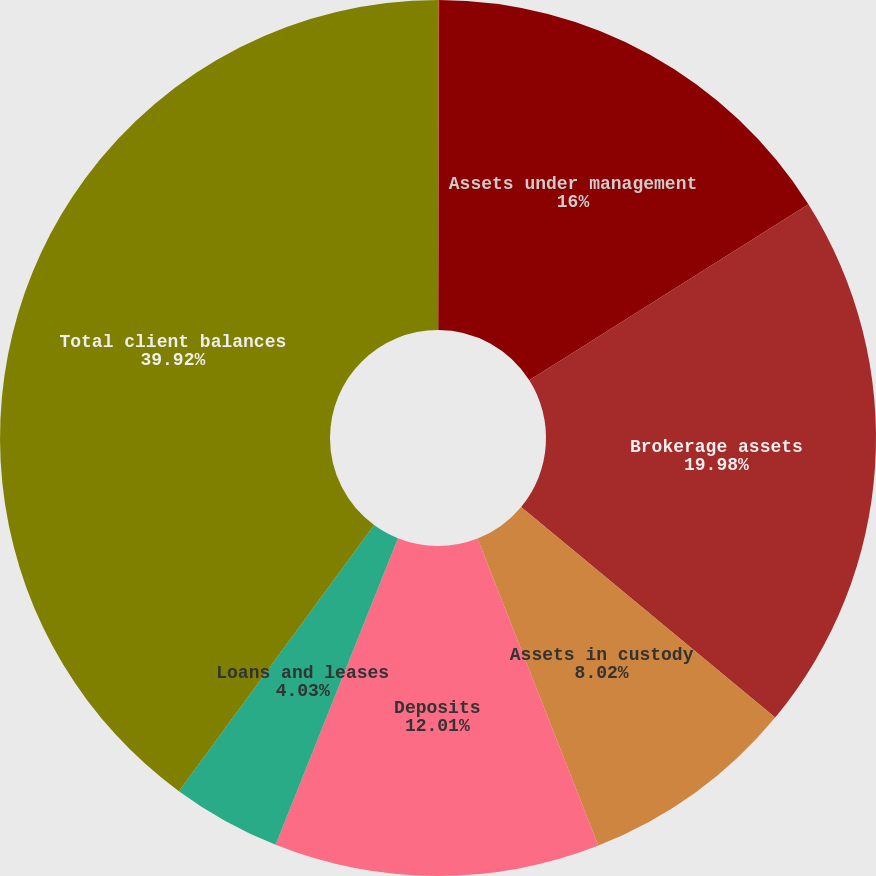<chart> <loc_0><loc_0><loc_500><loc_500><pie_chart><fcel>(Dollars in millions)<fcel>Assets under management<fcel>Brokerage assets<fcel>Assets in custody<fcel>Deposits<fcel>Loans and leases<fcel>Total client balances<nl><fcel>0.04%<fcel>16.0%<fcel>19.98%<fcel>8.02%<fcel>12.01%<fcel>4.03%<fcel>39.93%<nl></chart> 